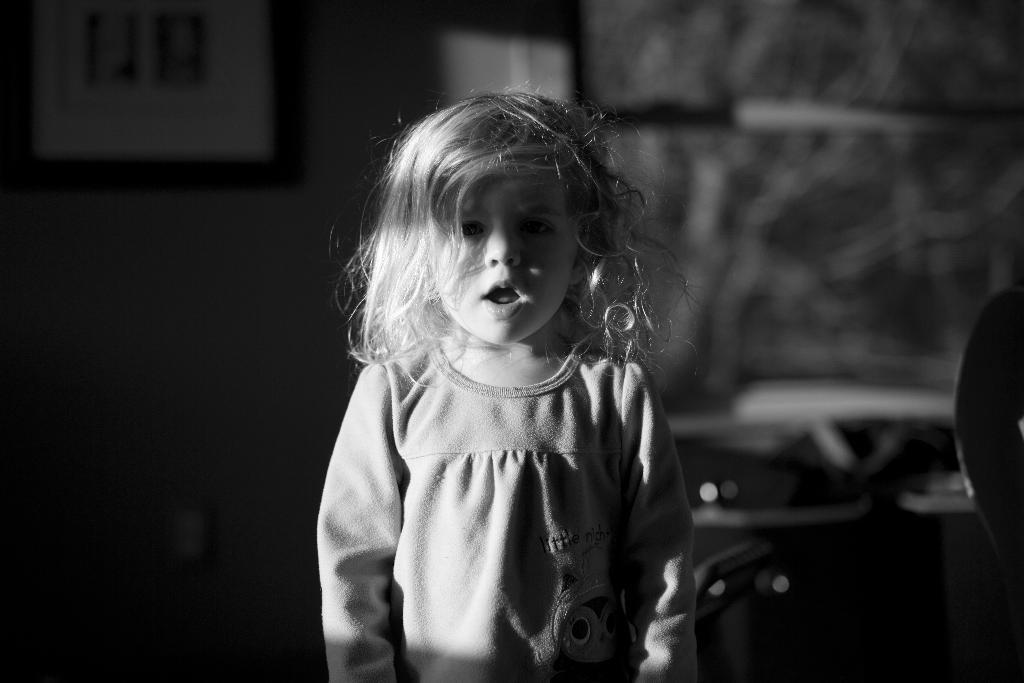Who is the main subject in the image? There is a girl in the image. What is the girl doing in the image? The girl has her mouth open. What can be seen on the wall in the background of the image? There is a frame on the wall in the background of the image. What else is visible in the background of the image? There are objects visible in the background of the image. What is the value of the planes flying in the image? There are no planes visible in the image, so it is not possible to determine their value. 